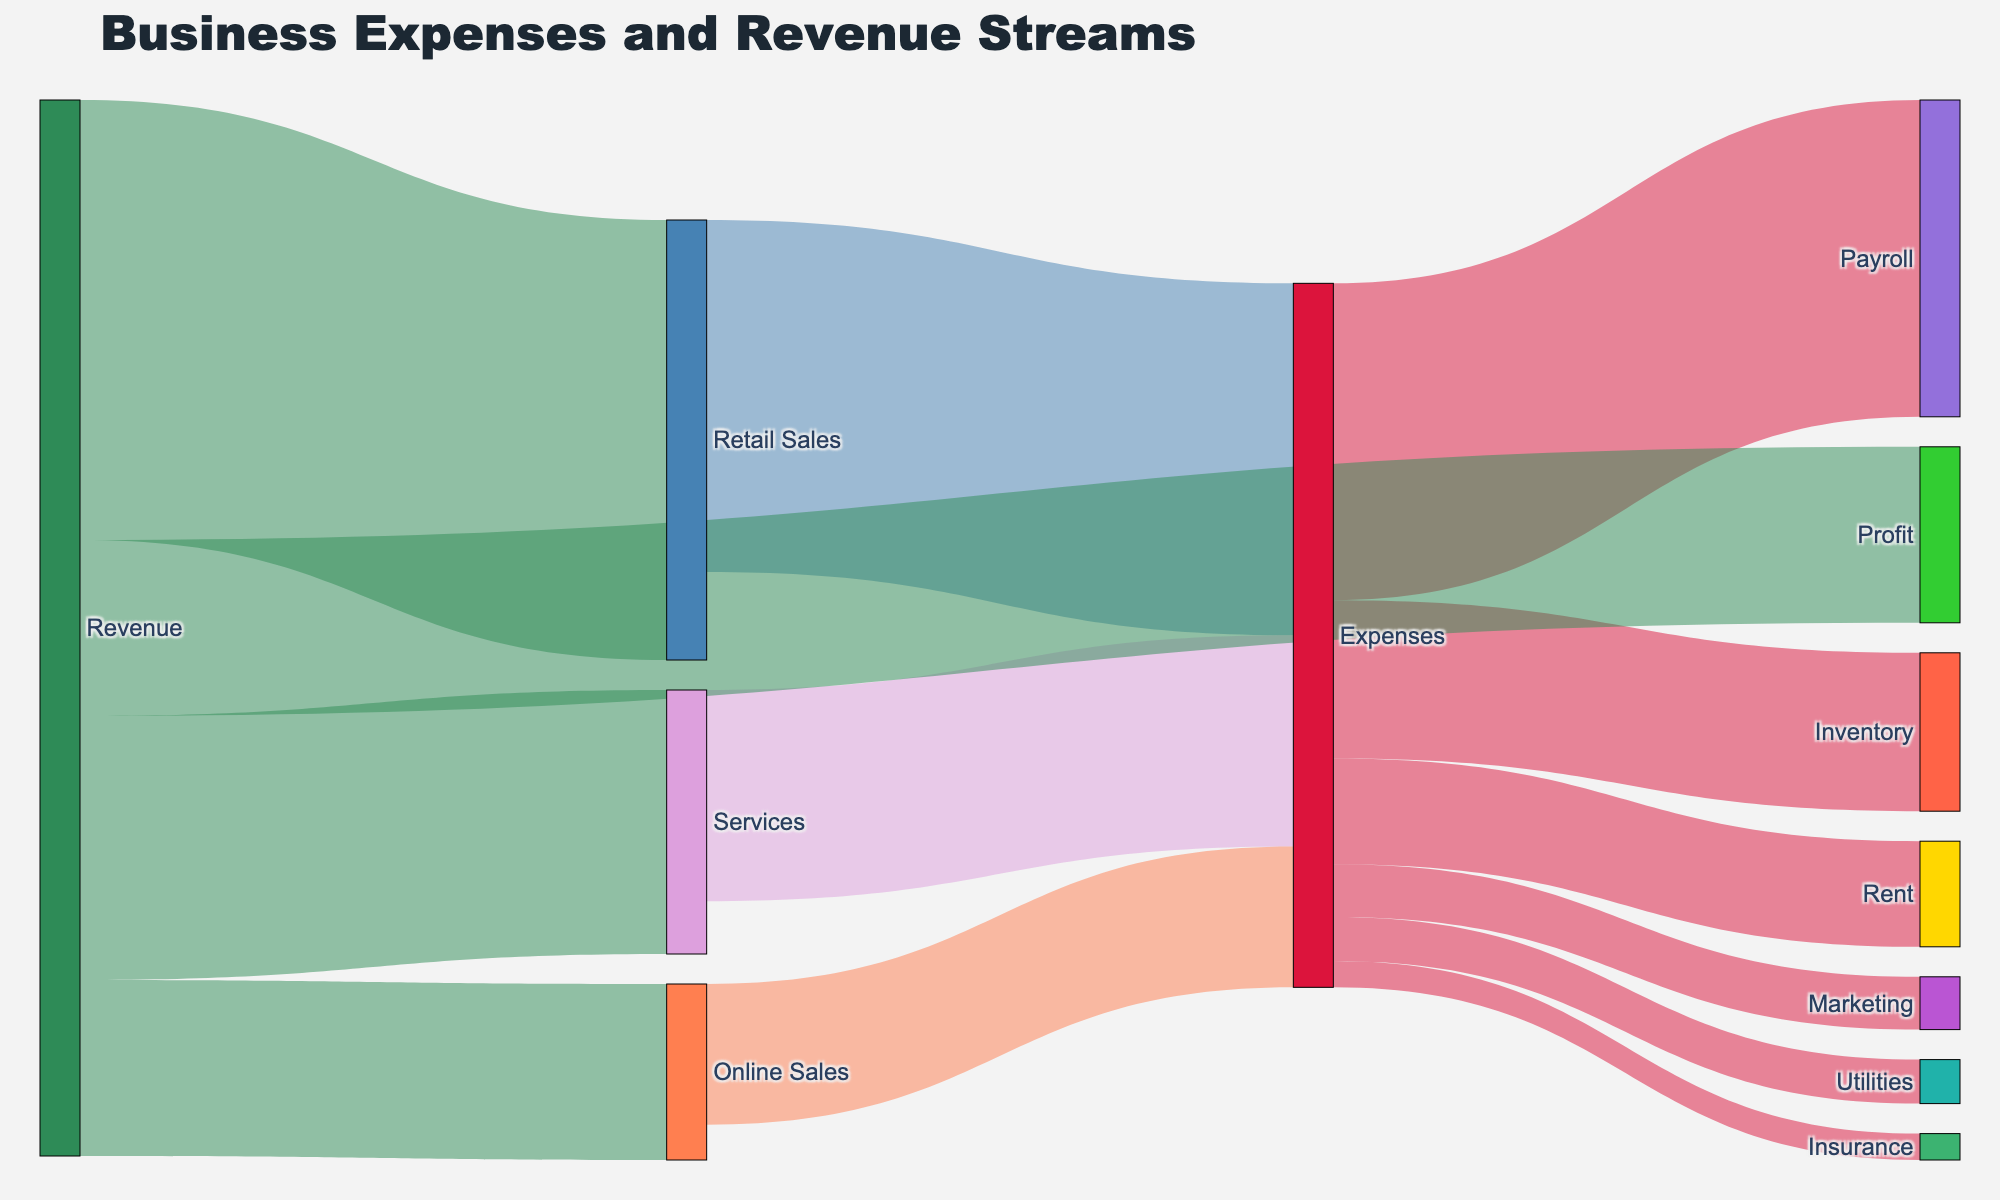How much profit did the business generate? The label "Profit" is shown with a flow from "Revenue" labeled as 100,000.
Answer: 100,000 What are the primary sources of revenue for the business? The sources labeled under "Revenue" are "Retail Sales", "Services", and "Online Sales".
Answer: Retail Sales, Services, Online Sales Which expense category has the highest value? By visually comparing the widths of the flows under "Expenses", "Payroll" has the highest value which is 180,000.
Answer: Payroll What is the total value of expenses? Sum all the flows under "Expenses" category: Rent (60,000) + Payroll (180,000) + Utilities (25,000) + Inventory (90,000) + Marketing (30,000) + Insurance (15,000) = 400,000
Answer: 400,000 Can you identify the largest source of revenue? "Retail Sales" has the largest flow under "Revenue" with a value of 250,000.
Answer: Retail Sales What are the components of expenses for Online Sales? Look at the flow from "Online Sales" under "Expenses", which is 80,000. This flow then connects to various categories under "Expenses".
Answer: Rent, Payroll, Utilities, Inventory, Marketing, Insurance How much did the business spend on rent? The flow from "Expenses" to "Rent" shows a value of 60,000.
Answer: 60,000 What percentage of the total revenue comes from Services? The total revenue is the sum of "Retail Sales" (250,000), "Services" (150,000), and "Online Sales" (100,000) = 500,000. The percentage for "Services" is (150,000 / 500,000) * 100 = 30%.
Answer: 30% Which category contributes the least to the total expenses? The smallest flow under "Expenses" is to "Insurance" with a value of 15,000.
Answer: Insurance 